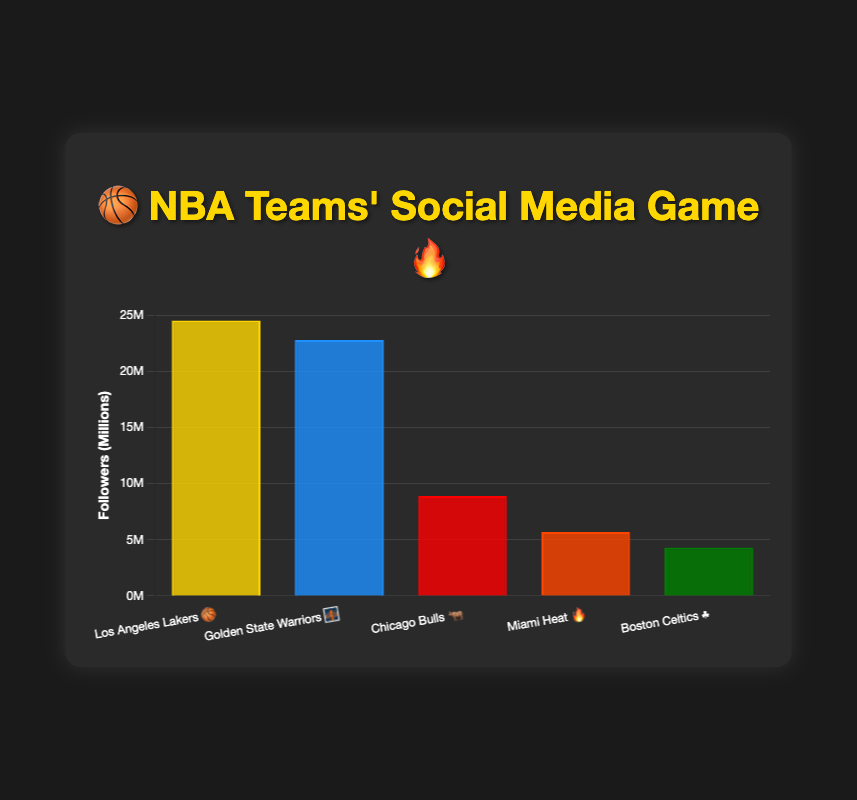What is the team with the most followers on social media? Look for the team with the highest bar in the chart. The Los Angeles Lakers have the tallest bar, indicating the most followers.
Answer: Los Angeles Lakers Which platform has the least followers among these teams? Identify the shortest bar in the chart. The Boston Celtics' bar is the shortest, indicating they have the fewest followers on Facebook.
Answer: Facebook How many more followers do the Los Angeles Lakers have compared to the Miami Heat? Subtract the Miami Heat’s followers from the Los Angeles Lakers’ followers: 24,500,000 - 5,700,000 = 18,800,000.
Answer: 18 million How many teams are represented in the chart? Count the number of labeled bars. There are five distinct teams shown.
Answer: 5 What's the combined total of Instagram followers for the Los Angeles Lakers and Golden State Warriors? Sum the followers of the two teams on Instagram: 24,500,000 + 22,800,000 = 47,300,000.
Answer: 47 million Which team on TikTok has more followers, and by how much over the team with the least followers on Facebook? Identify the teams on TikTok and Facebook, then compare their followers. Miami Heat has more TikTok followers and exceeds Boston Celtics' Facebook followers by: 5,700,000 - 4,300,000 = 1,400,000.
Answer: Miami Heat, 1.4 million What percentage of the total followers does the Chicago Bulls have? Calculate the total followers first: 24,500,000 + 22,800,000 + 8,900,000 + 5,700,000 + 4,300,000 = 66,200,000. Then, divide the Chicago Bulls' followers by this number and multiply by 100: (8,900,000 / 66,200,000) * 100 ≈ 13.4%.
Answer: 13% Between the Golden State Warriors and the Chicago Bulls, who has more followers, and by how much? Compare the followers of both teams: 22,800,000 (Warriors) - 8,900,000 (Bulls) = 13,900,000.
Answer: Golden State Warriors, 13.9 million Is the average number of followers for the Miami Heat and Boston Celtics greater or less than 6 million? Calculate the average: (5,700,000 + 4,300,000) / 2 = 5,000,000. Check if it's greater or less than 6 million.
Answer: Less What is the combined number of social media followers for all teams? Add the followers of all five teams together: 24,500,000 + 22,800,000 + 8,900,000 + 5,700,000 + 4,300,000 = 66,200,000.
Answer: 66 million 